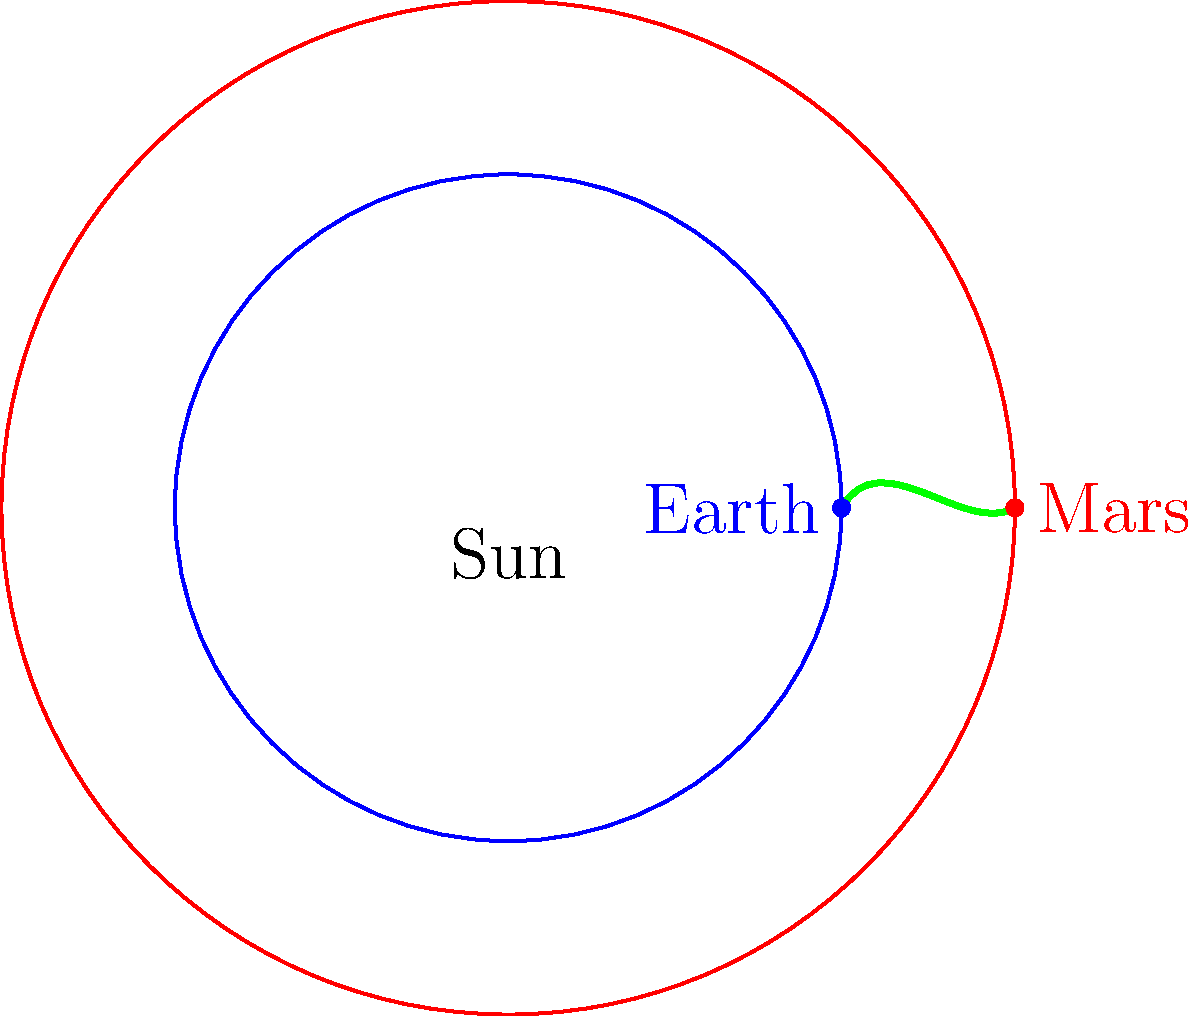A spacecraft is launched from Earth to Mars using a Hohmann transfer orbit. Given that the average distance from the Sun to Earth is 1 AU (Astronomical Unit) and the average distance from the Sun to Mars is 1.52 AU, what is the semi-major axis of the transfer orbit in AU? To find the semi-major axis of the Hohmann transfer orbit, we can follow these steps:

1. Recall that a Hohmann transfer orbit is an elliptical orbit that touches both the origin and destination orbits at its perihelion and aphelion, respectively.

2. The semi-major axis of an ellipse is half the sum of its perihelion and aphelion distances.

3. In this case:
   - Perihelion distance (Earth's orbit) = 1 AU
   - Aphelion distance (Mars' orbit) = 1.52 AU

4. Calculate the semi-major axis:
   $$ a = \frac{r_1 + r_2}{2} $$
   Where:
   $a$ = semi-major axis
   $r_1$ = perihelion distance (Earth's orbit)
   $r_2$ = aphelion distance (Mars' orbit)

5. Plug in the values:
   $$ a = \frac{1 + 1.52}{2} = \frac{2.52}{2} = 1.26 \text{ AU} $$

Therefore, the semi-major axis of the Hohmann transfer orbit from Earth to Mars is 1.26 AU.
Answer: 1.26 AU 